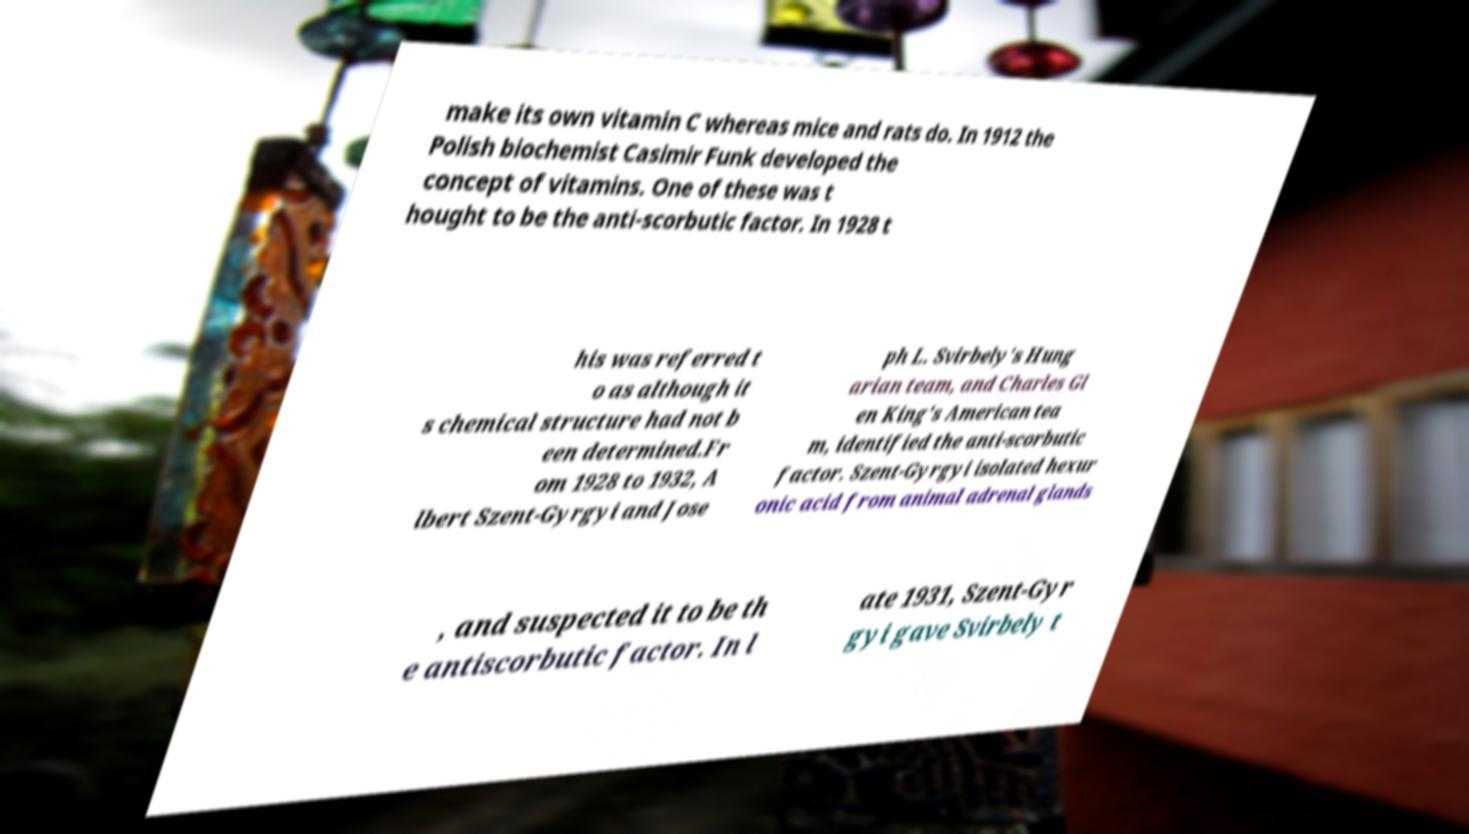Can you accurately transcribe the text from the provided image for me? make its own vitamin C whereas mice and rats do. In 1912 the Polish biochemist Casimir Funk developed the concept of vitamins. One of these was t hought to be the anti-scorbutic factor. In 1928 t his was referred t o as although it s chemical structure had not b een determined.Fr om 1928 to 1932, A lbert Szent-Gyrgyi and Jose ph L. Svirbely's Hung arian team, and Charles Gl en King's American tea m, identified the anti-scorbutic factor. Szent-Gyrgyi isolated hexur onic acid from animal adrenal glands , and suspected it to be th e antiscorbutic factor. In l ate 1931, Szent-Gyr gyi gave Svirbely t 